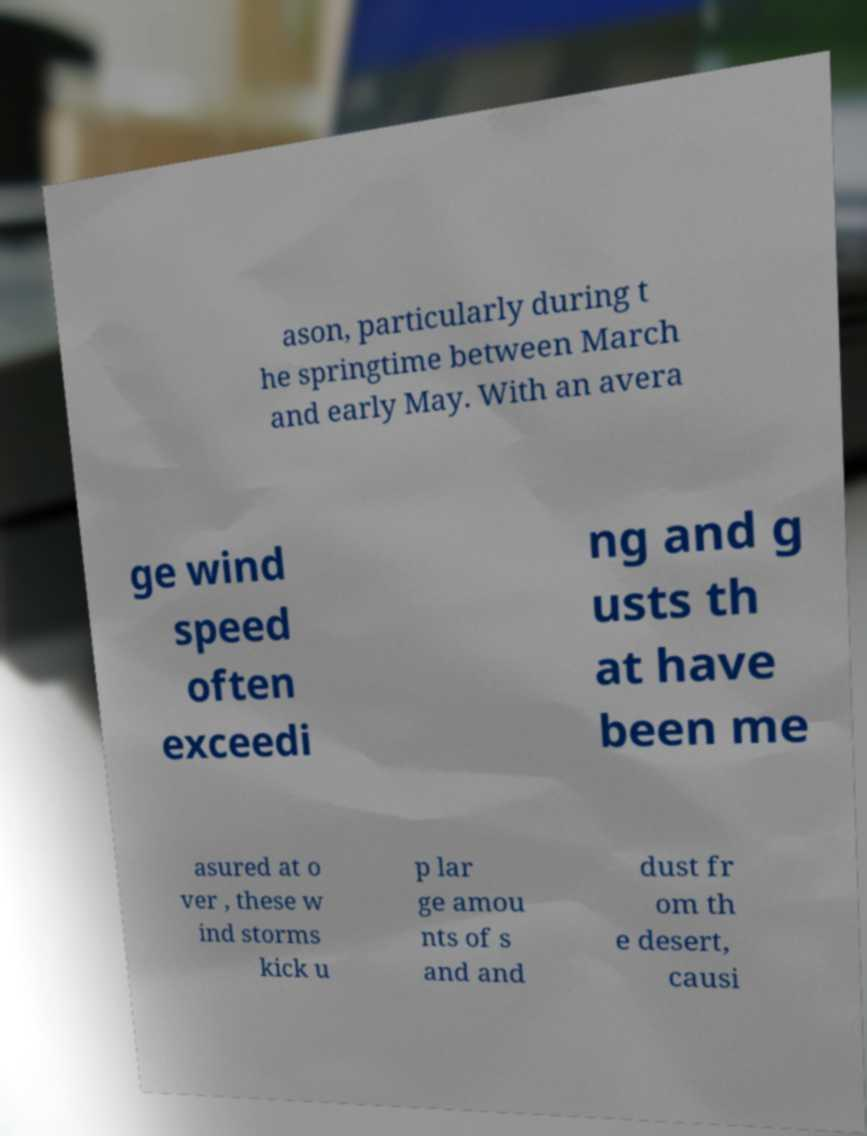Please read and relay the text visible in this image. What does it say? ason, particularly during t he springtime between March and early May. With an avera ge wind speed often exceedi ng and g usts th at have been me asured at o ver , these w ind storms kick u p lar ge amou nts of s and and dust fr om th e desert, causi 